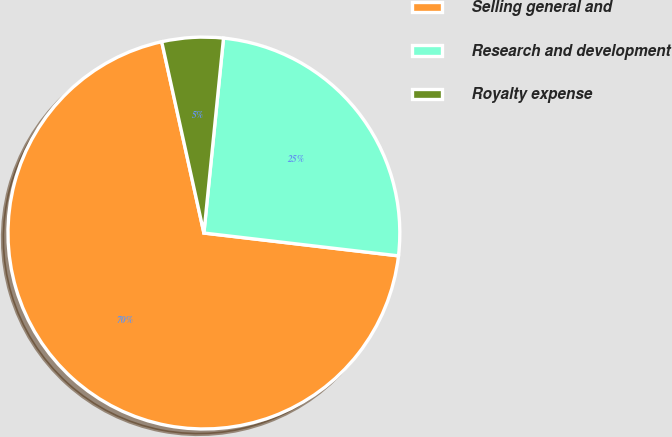Convert chart to OTSL. <chart><loc_0><loc_0><loc_500><loc_500><pie_chart><fcel>Selling general and<fcel>Research and development<fcel>Royalty expense<nl><fcel>69.68%<fcel>25.26%<fcel>5.05%<nl></chart> 